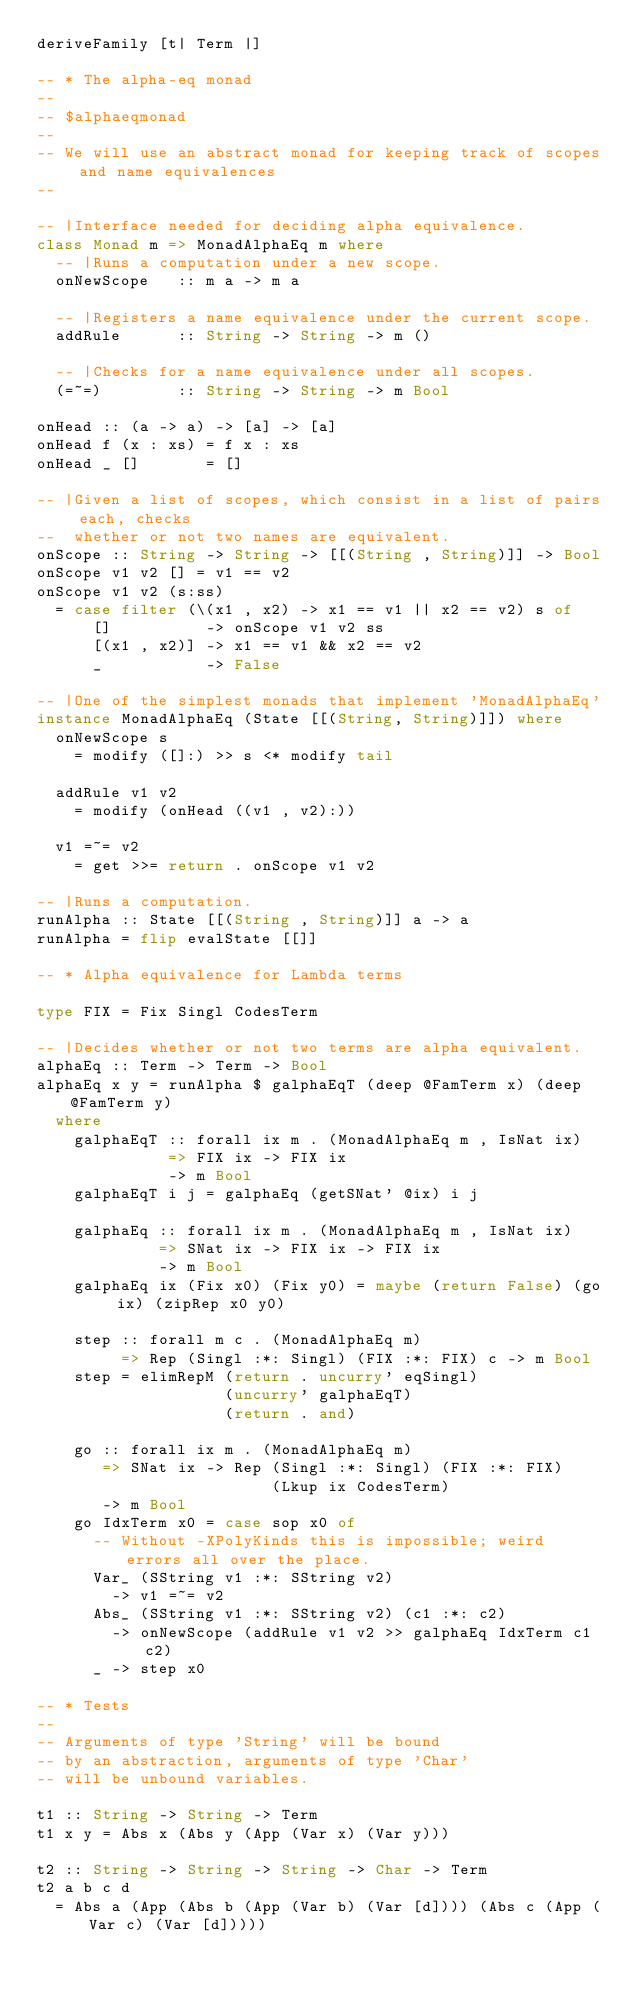<code> <loc_0><loc_0><loc_500><loc_500><_Haskell_>deriveFamily [t| Term |]

-- * The alpha-eq monad
--
-- $alphaeqmonad
--
-- We will use an abstract monad for keeping track of scopes and name equivalences
--

-- |Interface needed for deciding alpha equivalence.
class Monad m => MonadAlphaEq m where
  -- |Runs a computation under a new scope.
  onNewScope   :: m a -> m a

  -- |Registers a name equivalence under the current scope.
  addRule      :: String -> String -> m ()
  
  -- |Checks for a name equivalence under all scopes.
  (=~=)        :: String -> String -> m Bool

onHead :: (a -> a) -> [a] -> [a]
onHead f (x : xs) = f x : xs
onHead _ []       = []

-- |Given a list of scopes, which consist in a list of pairs each, checks
--  whether or not two names are equivalent.
onScope :: String -> String -> [[(String , String)]] -> Bool
onScope v1 v2 [] = v1 == v2
onScope v1 v2 (s:ss)
  = case filter (\(x1 , x2) -> x1 == v1 || x2 == v2) s of
      []          -> onScope v1 v2 ss
      [(x1 , x2)] -> x1 == v1 && x2 == v2
      _           -> False

-- |One of the simplest monads that implement 'MonadAlphaEq'
instance MonadAlphaEq (State [[(String, String)]]) where
  onNewScope s
    = modify ([]:) >> s <* modify tail

  addRule v1 v2
    = modify (onHead ((v1 , v2):))

  v1 =~= v2
    = get >>= return . onScope v1 v2

-- |Runs a computation.
runAlpha :: State [[(String , String)]] a -> a
runAlpha = flip evalState [[]]

-- * Alpha equivalence for Lambda terms

type FIX = Fix Singl CodesTerm

-- |Decides whether or not two terms are alpha equivalent.
alphaEq :: Term -> Term -> Bool
alphaEq x y = runAlpha $ galphaEqT (deep @FamTerm x) (deep @FamTerm y)
  where
    galphaEqT :: forall ix m . (MonadAlphaEq m , IsNat ix)
              => FIX ix -> FIX ix
              -> m Bool
    galphaEqT i j = galphaEq (getSNat' @ix) i j

    galphaEq :: forall ix m . (MonadAlphaEq m , IsNat ix)
             => SNat ix -> FIX ix -> FIX ix
             -> m Bool
    galphaEq ix (Fix x0) (Fix y0) = maybe (return False) (go ix) (zipRep x0 y0)

    step :: forall m c . (MonadAlphaEq m)
         => Rep (Singl :*: Singl) (FIX :*: FIX) c -> m Bool
    step = elimRepM (return . uncurry' eqSingl)
                    (uncurry' galphaEqT)
                    (return . and)

    go :: forall ix m . (MonadAlphaEq m)
       => SNat ix -> Rep (Singl :*: Singl) (FIX :*: FIX)
                         (Lkup ix CodesTerm)
       -> m Bool
    go IdxTerm x0 = case sop x0 of
      -- Without -XPolyKinds this is impossible; weird errors all over the place.
      Var_ (SString v1 :*: SString v2)
        -> v1 =~= v2
      Abs_ (SString v1 :*: SString v2) (c1 :*: c2)
        -> onNewScope (addRule v1 v2 >> galphaEq IdxTerm c1 c2)
      _ -> step x0

-- * Tests
--
-- Arguments of type 'String' will be bound
-- by an abstraction, arguments of type 'Char'
-- will be unbound variables.

t1 :: String -> String -> Term
t1 x y = Abs x (Abs y (App (Var x) (Var y)))

t2 :: String -> String -> String -> Char -> Term
t2 a b c d
  = Abs a (App (Abs b (App (Var b) (Var [d]))) (Abs c (App (Var c) (Var [d]))))
</code> 